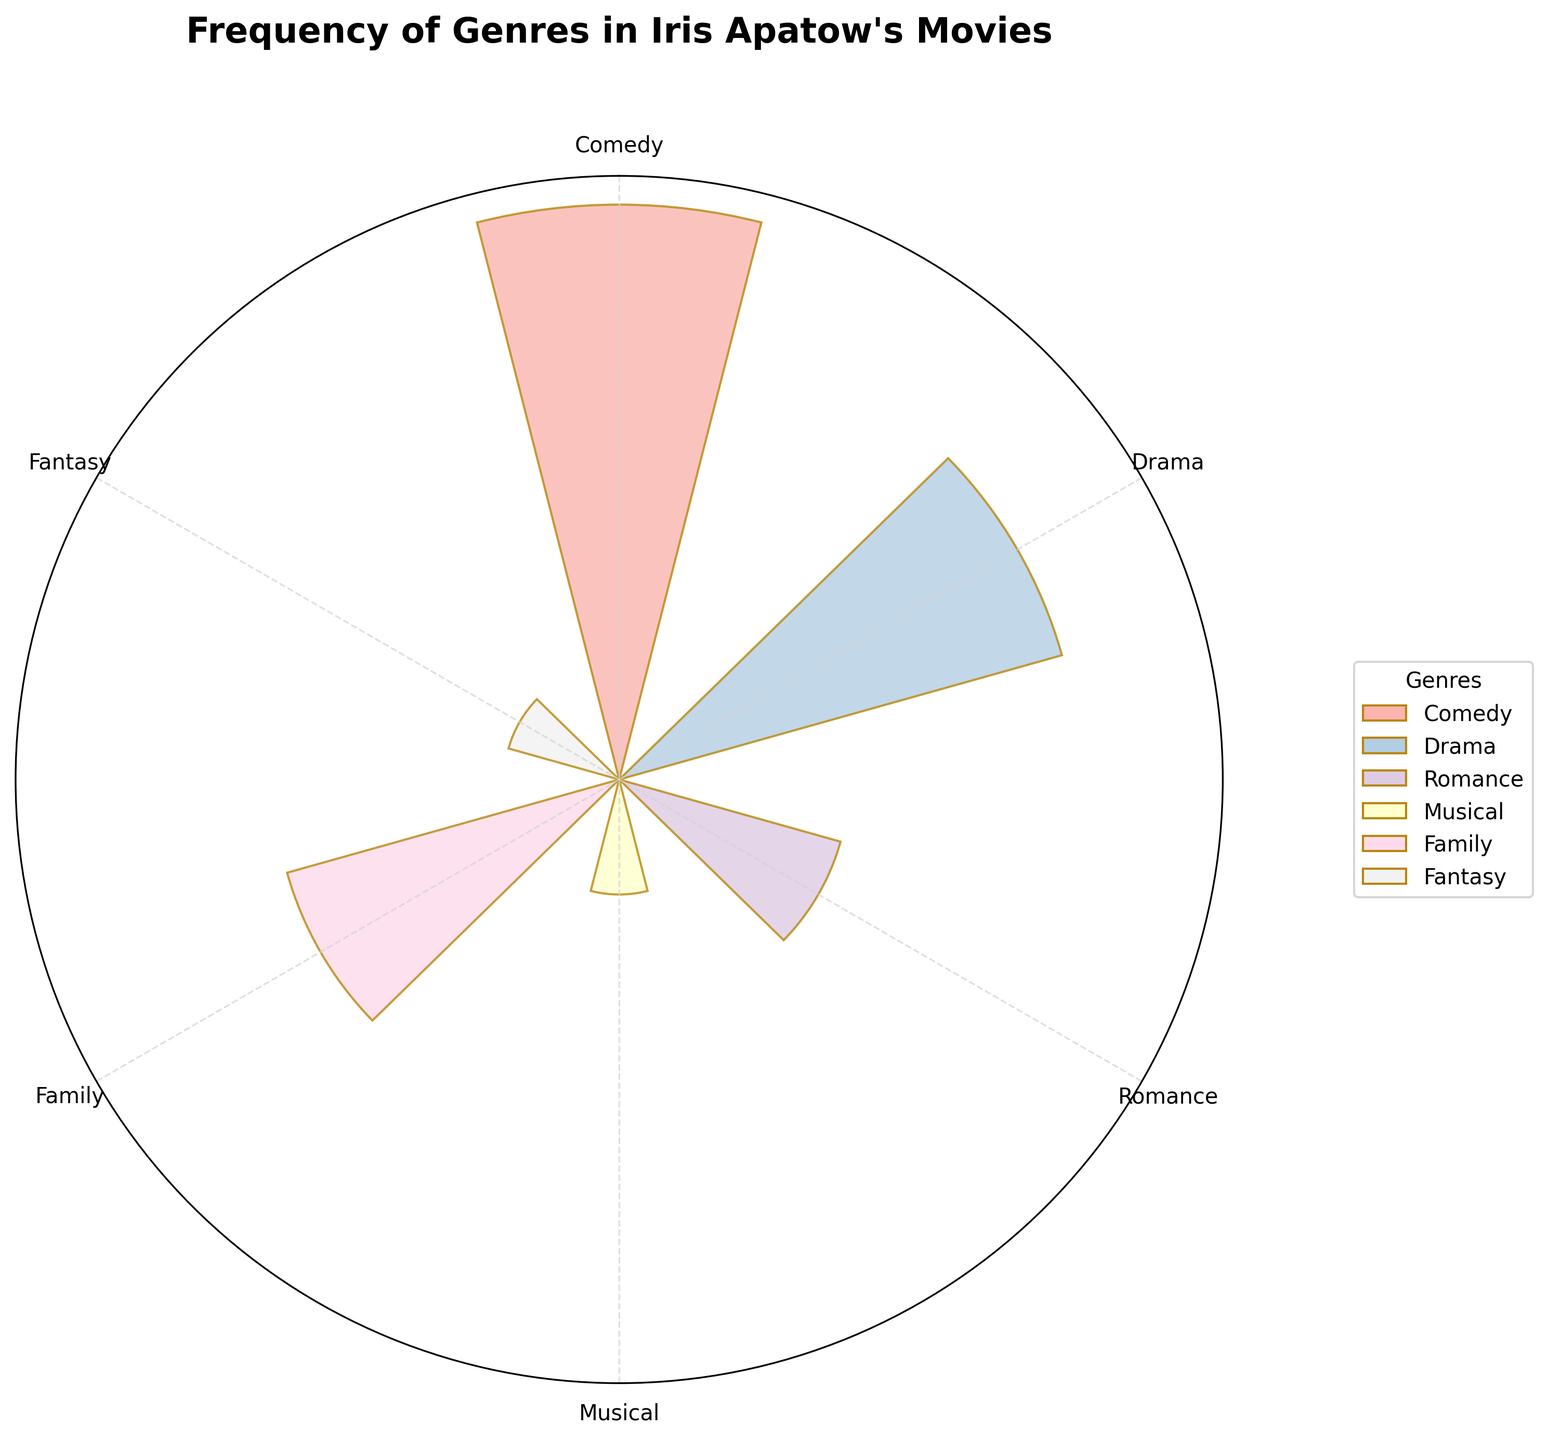What is the title of the figure? The title is located at the top center of the figure and is usually the largest text present.
Answer: Frequency of Genres in Iris Apatow's Movies How many genres are represented in the chart? The chart includes all data points corresponding to distinct genres, each labeled on the radial axis. By counting these labels, we can determine the number of genres.
Answer: 6 Which genre has the highest frequency? By examining the heights of the bars, the genre with the highest bar represents the highest frequency. The label at this position indicates the genre.
Answer: Comedy What are the colors used in the chart? Each bar has a unique pastel color, and the exact shades can be inferred from the visual spectrum presented in the plot.
Answer: Various pastel colors (e.g., light pink, light blue) Which genres have the same frequency of 1? By looking at the bars that extend to the same height ending at 1 on the radial plot, and noting the labels attached to those bars, we can identify the genres.
Answer: Musical and Fantasy What is the combined frequency of Drama and Family genres? Locate the frequencies for both Drama and Family on the chart (Drama: 4, Family: 3) and sum them.
Answer: 7 How does the frequency of Romance compare to that of Family? Compare the heights of bars corresponding to Romance (2) and Family (3). Determine whether Romance is less, equal to, or greater than Family.
Answer: Less than What is the average frequency of all genres? Sum all frequencies (5 + 4 + 2 + 1 + 3 + 1) and divide by the total number of genres (6).
Answer: 2.67 What is the difference in frequency between the most and least frequent genres? Identify the highest (Comedy: 5) and lowest (Musical, Fantasy: 1) frequencies and calculate the difference.
Answer: 4 Which genre is positioned at the initial angle (top, 0/360 degrees) in the chart? The genre positioned at the topmost label, aligning with the initial angle of the polar plot, can be identified.
Answer: Comedy 